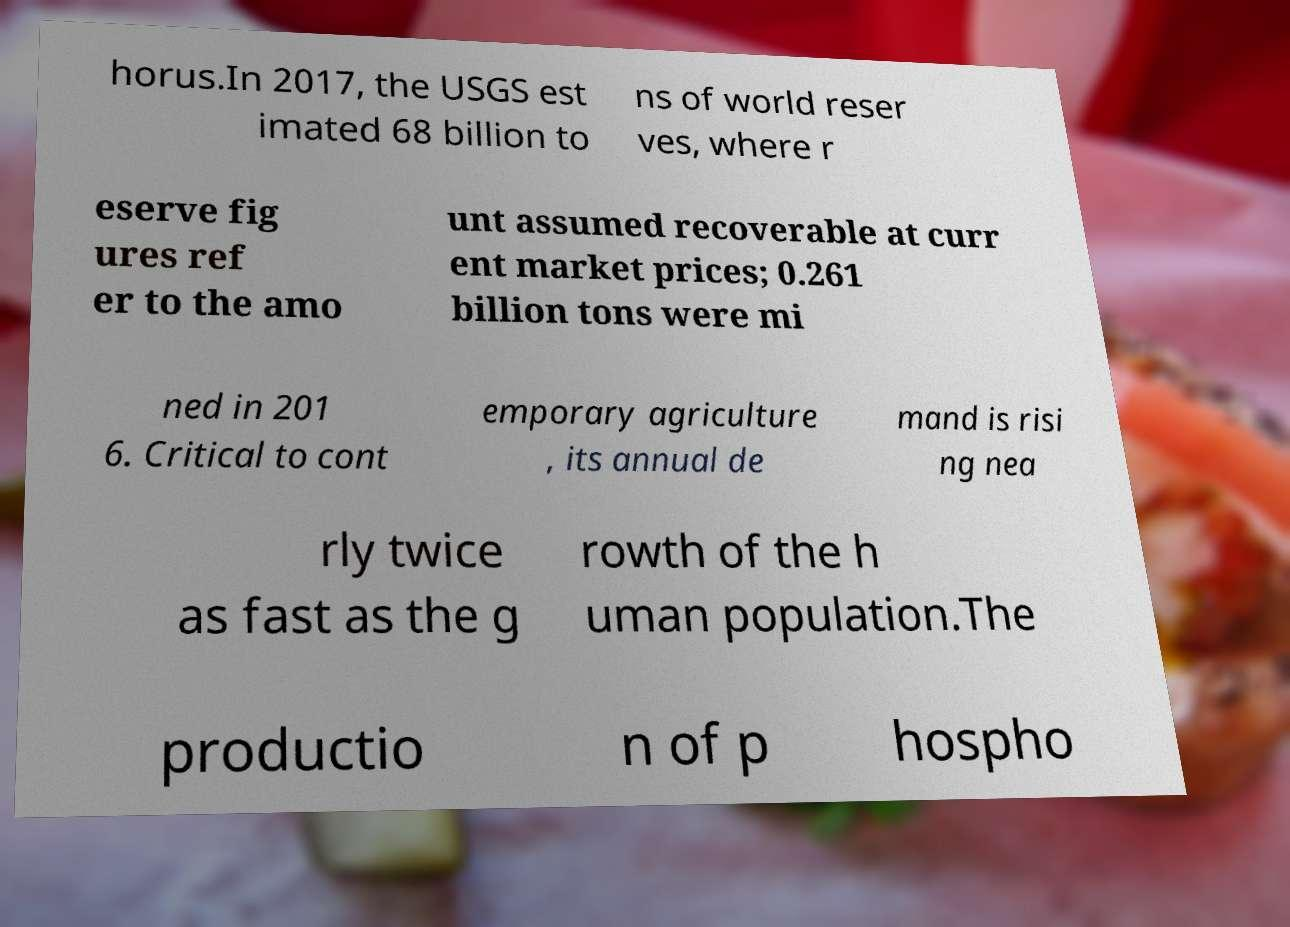Please read and relay the text visible in this image. What does it say? horus.In 2017, the USGS est imated 68 billion to ns of world reser ves, where r eserve fig ures ref er to the amo unt assumed recoverable at curr ent market prices; 0.261 billion tons were mi ned in 201 6. Critical to cont emporary agriculture , its annual de mand is risi ng nea rly twice as fast as the g rowth of the h uman population.The productio n of p hospho 